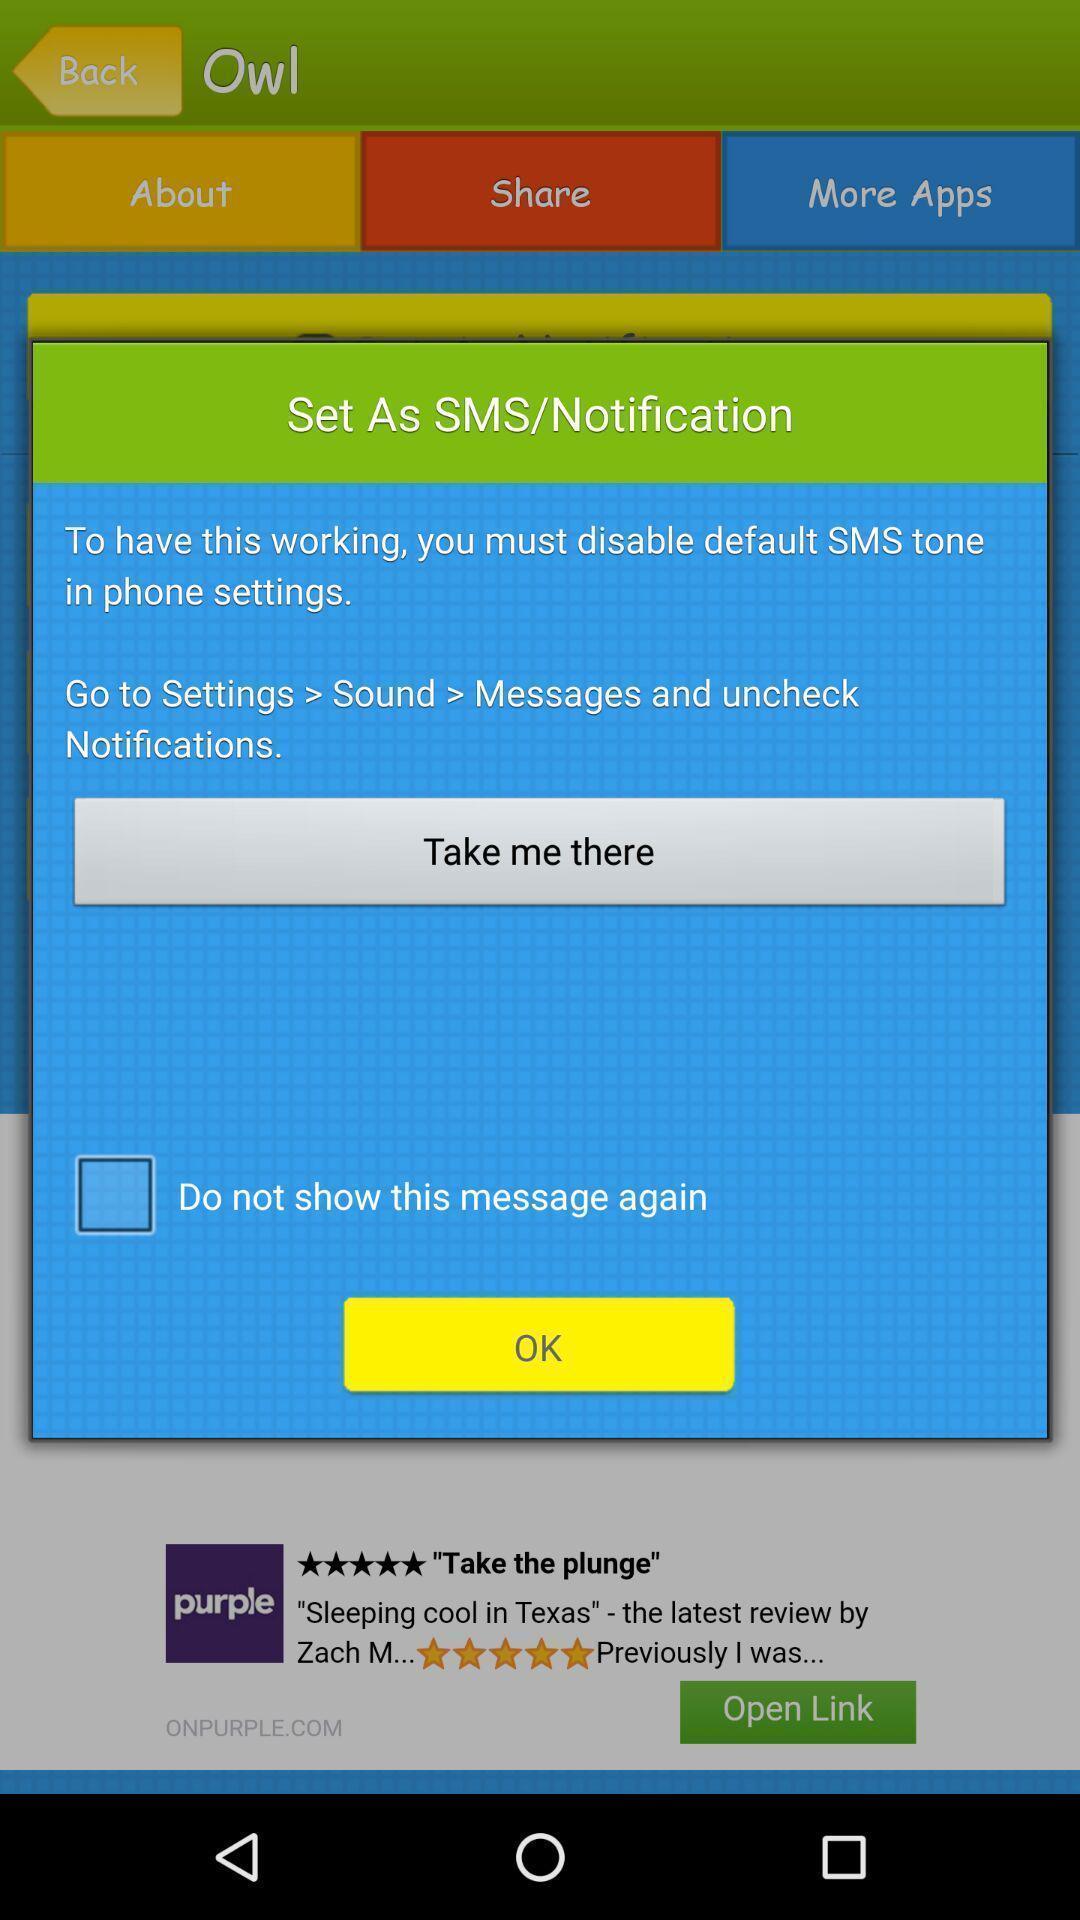Describe the key features of this screenshot. Pop up window for setting notification. 